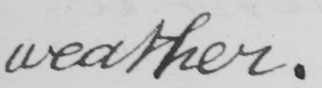What text is written in this handwritten line? weather. 